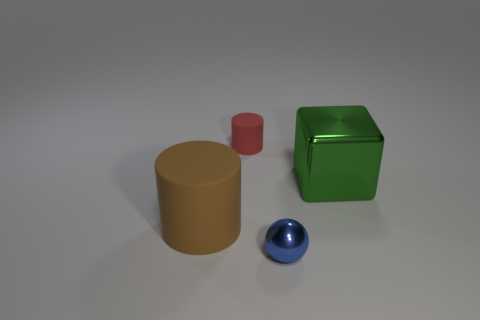What colors are the objects near the green cube? The objects near the green cube are yellow, red, and blue. 